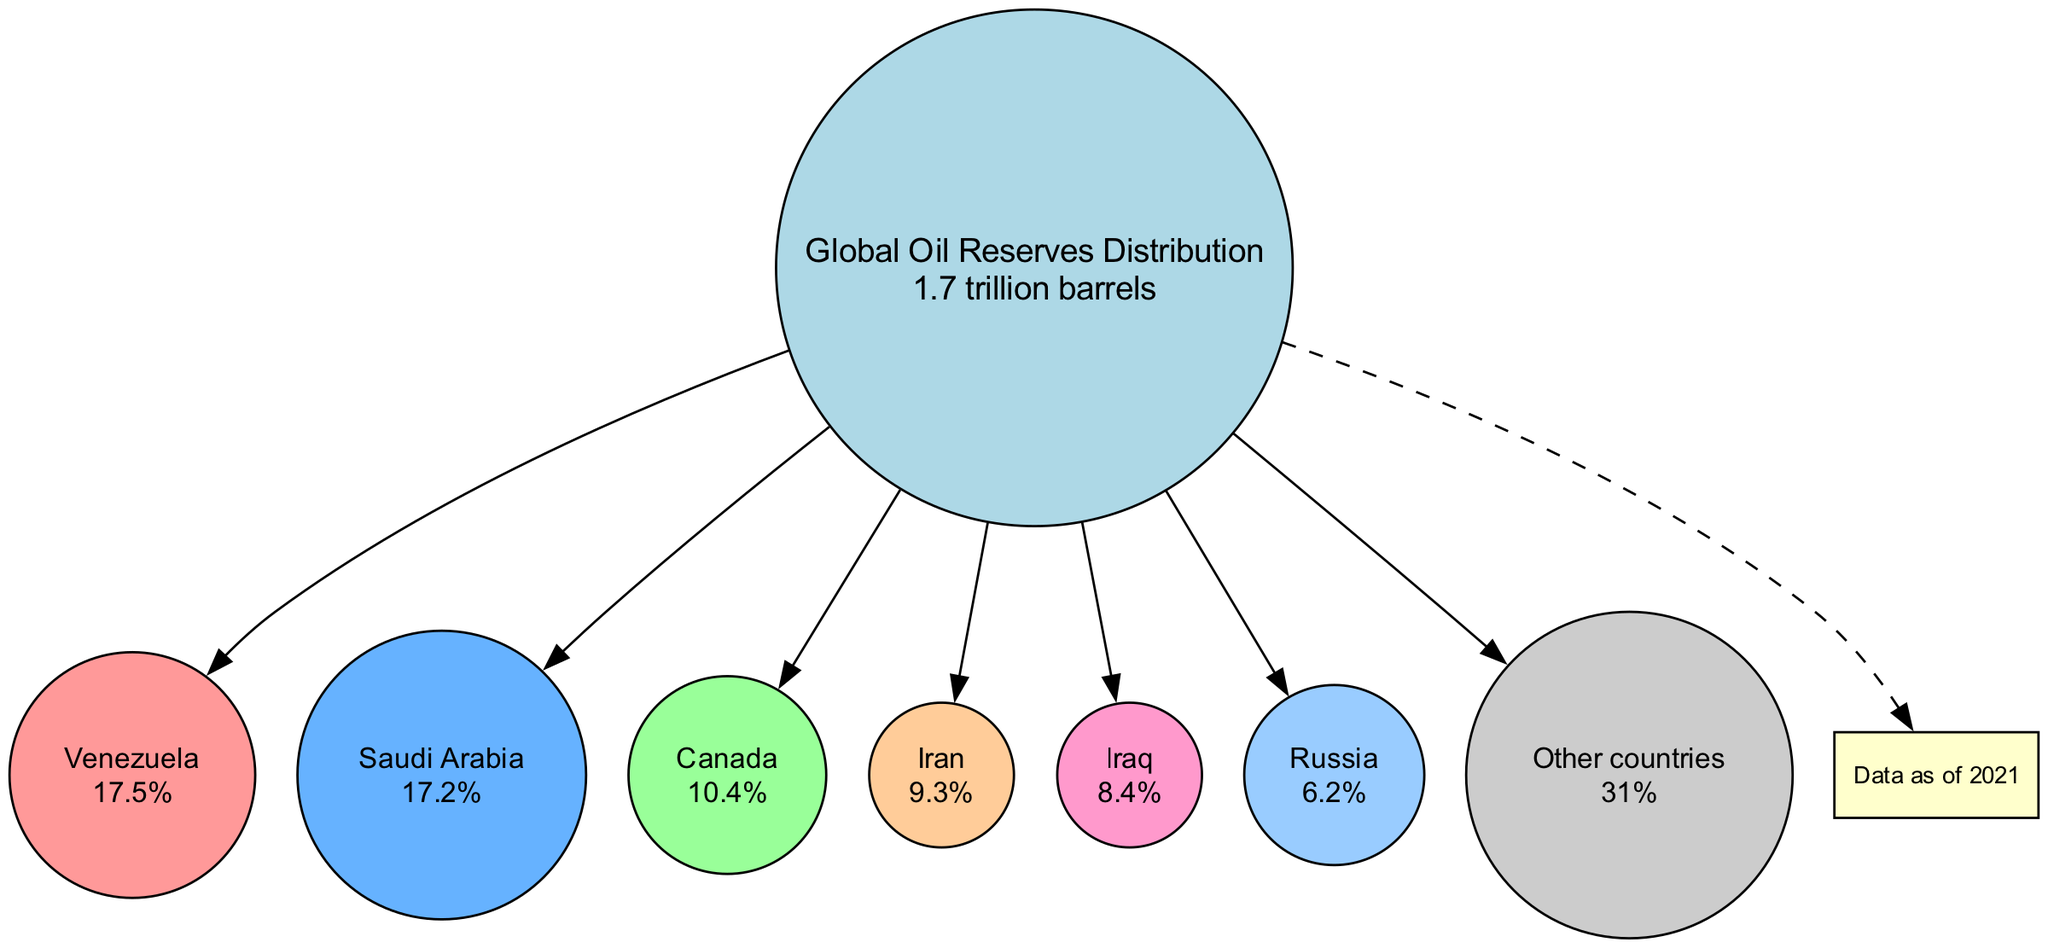What country has the highest percentage of oil reserves? By observing the pie chart, I can see that Venezuela, which is listed first in the countries' list, has the highest percentage of oil reserves at 17.5%.
Answer: Venezuela What percentage of global oil reserves is held by Saudi Arabia? The pie chart clearly states that Saudi Arabia holds 17.2% of global oil reserves.
Answer: 17.2% How many countries are specifically mentioned in the diagram? The diagram lists six specific countries plus a category for "Other countries," making the total count of mentioned entities seven.
Answer: 7 What is the combined percentage of the top three countries (Venezuela, Saudi Arabia, and Canada)? To find this, I add Venezuela's 17.5%, Saudi Arabia's 17.2%, and Canada's 10.4%. The sum is 45.1%.
Answer: 45.1% Which category represents the largest portion of global oil reserves? Upon reviewing the diagram, "Other countries" is identified as holding the largest share at 31%.
Answer: Other countries What is the total percentage of reserves held by Iran and Iraq together? The combined percentage of Iran (9.3%) and Iraq (8.4%) is calculated by adding these two values together, resulting in 17.7%.
Answer: 17.7% Which country has a percentage closest to 10% in the diagram? In this pie chart, Canada has a percentage of 10.4%, which is closest to 10% among the listed countries.
Answer: Canada What is the total volume of global oil reserves represented in the diagram? The title of the diagram states the total reserves amount to 1.7 trillion barrels.
Answer: 1.7 trillion barrels What color is used to represent Iran in the diagram? The diagram uses a specific color from a palette; looking at Iran's entry, it is identified with a light orange hue.
Answer: Light orange 